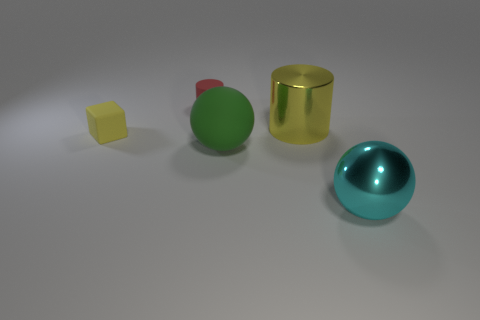What color is the shiny object that is to the left of the shiny object that is in front of the large yellow thing?
Give a very brief answer. Yellow. What size is the cylinder that is made of the same material as the yellow cube?
Your answer should be very brief. Small. What number of other big matte things are the same shape as the big matte object?
Provide a succinct answer. 0. How many things are either large things that are in front of the tiny yellow block or objects to the left of the large cyan sphere?
Your answer should be very brief. 5. There is a rubber object behind the yellow block; what number of green balls are to the left of it?
Offer a very short reply. 0. Do the big shiny object that is in front of the tiny yellow thing and the big object that is behind the big green rubber sphere have the same shape?
Ensure brevity in your answer.  No. The metal thing that is the same color as the tiny cube is what shape?
Offer a very short reply. Cylinder. Are there any tiny red things that have the same material as the small yellow object?
Give a very brief answer. Yes. How many metallic objects are tiny red cylinders or large blue things?
Offer a terse response. 0. What is the shape of the large shiny object in front of the yellow thing that is on the left side of the small red object?
Give a very brief answer. Sphere. 